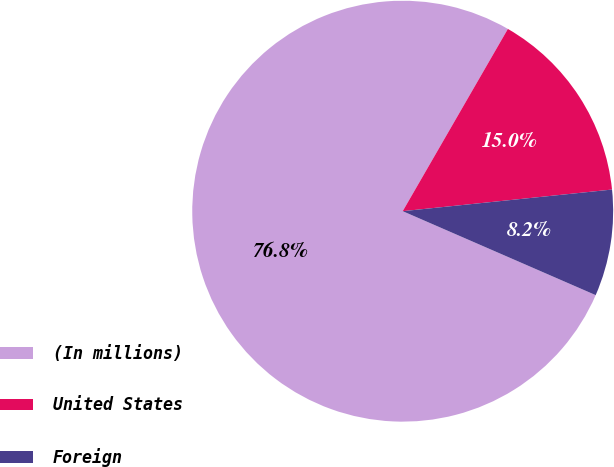<chart> <loc_0><loc_0><loc_500><loc_500><pie_chart><fcel>(In millions)<fcel>United States<fcel>Foreign<nl><fcel>76.8%<fcel>15.03%<fcel>8.17%<nl></chart> 